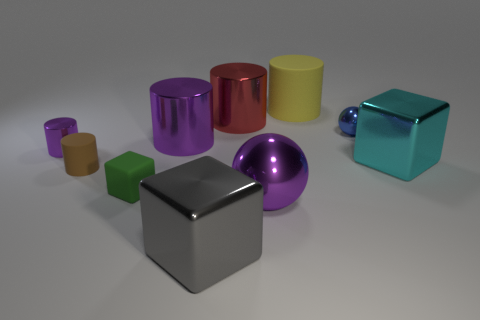Subtract all yellow rubber cylinders. How many cylinders are left? 4 Subtract all purple cylinders. How many cylinders are left? 3 Subtract 1 balls. How many balls are left? 1 Subtract 1 green blocks. How many objects are left? 9 Subtract all blocks. How many objects are left? 7 Subtract all cyan cubes. Subtract all gray cylinders. How many cubes are left? 2 Subtract all brown cylinders. How many blue blocks are left? 0 Subtract all tiny purple shiny objects. Subtract all tiny cubes. How many objects are left? 8 Add 7 red objects. How many red objects are left? 8 Add 3 big spheres. How many big spheres exist? 4 